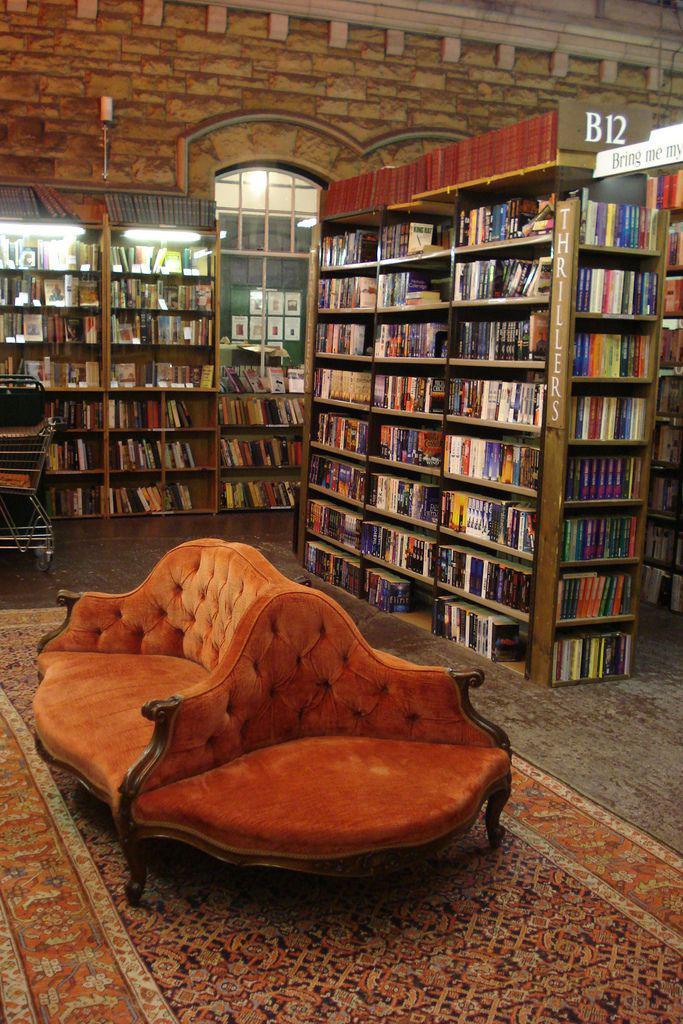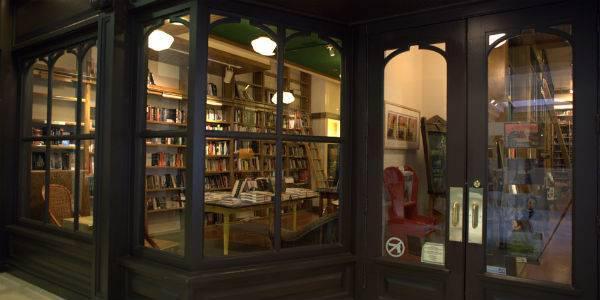The first image is the image on the left, the second image is the image on the right. Assess this claim about the two images: "An interior features bookshelves under at least one arch shape at the back, and upholstered furniture in front.". Correct or not? Answer yes or no. Yes. 